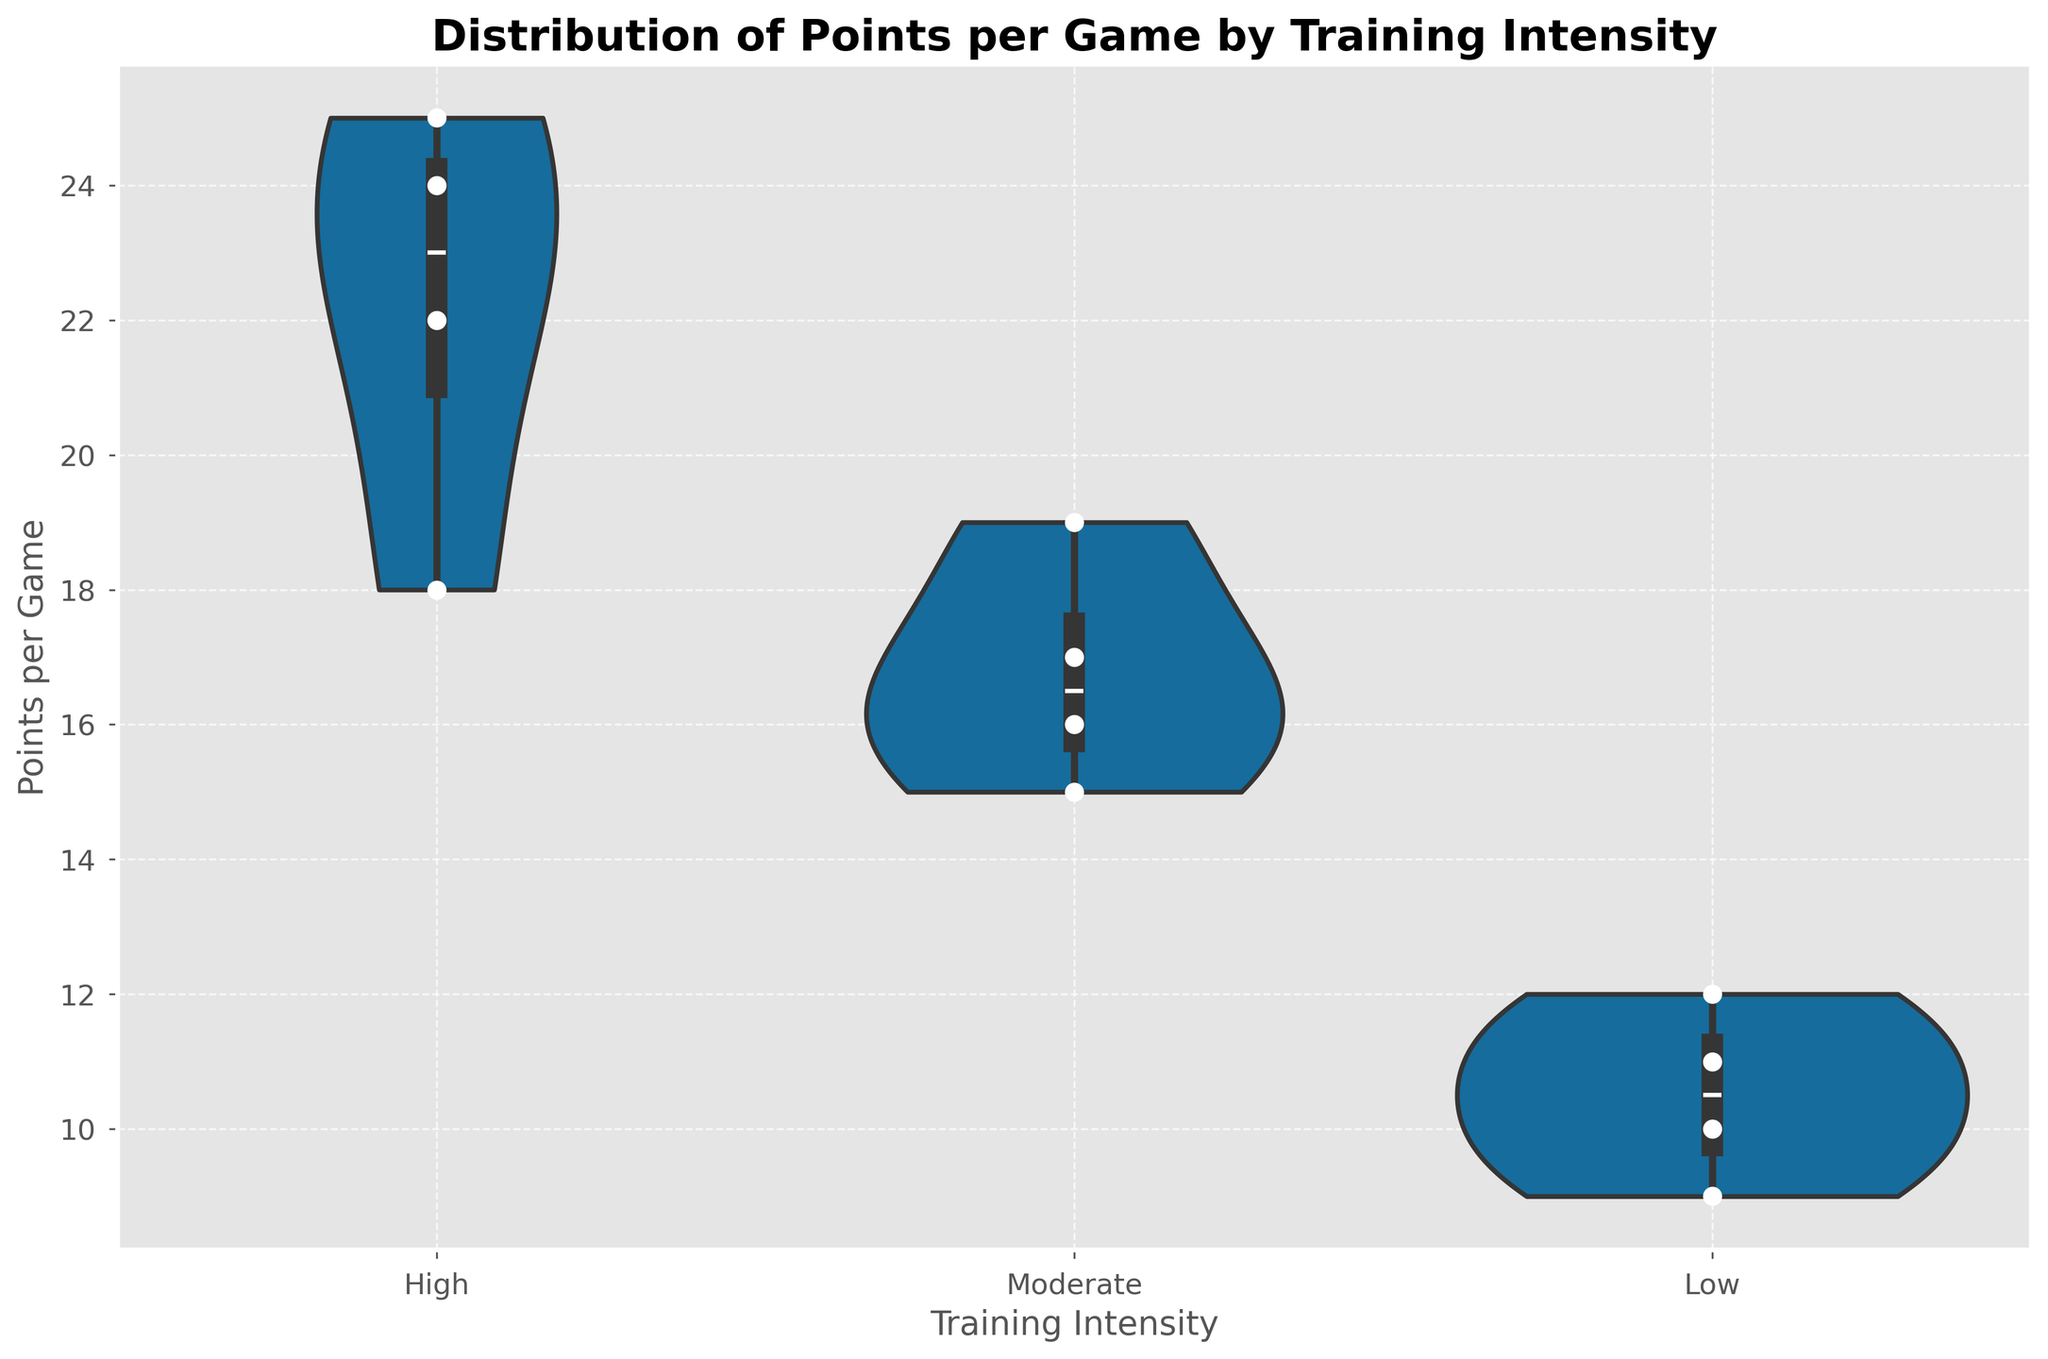What is the title of the figure? The title is shown at the top of the figure, and it provides an overview of the content of the plot.
Answer: Distribution of Points per Game by Training Intensity How many training intensity levels are represented on the x-axis? The x-axis displays the categories being compared, in this case, the different training intensity levels.
Answer: Three Which training intensity level has the highest median points per game? To determine the highest median, you observe the white dot in each violin plot, which represents the median value.
Answer: High What is the range of points per game for the 'Low' training intensity group? The range is obtained by looking at the top and bottom values of the 'Low' training intensity violin plot.
Answer: 9 to 12 Which training intensity level has the most densely packed points near the median? The density near the median is indicated by the width of the violin plot around the median (white dot).
Answer: High How many data points are represented for the 'Moderate' training intensity group? Each dot in the swarm plot represents an individual data point; count the dots for 'Moderate' training intensity.
Answer: Four Compare the spread of points per game between 'High' and 'Low' training intensities; which one is wider? The spread can be compared by the height of the violin plots.
Answer: High What is the interquartile range (IQR) for the 'High' training intensity group? The IQR is the range between the first quartile (25th percentile) and the third quartile (75th percentile) shown by the width of the darker part of the violin plot.
Answer: 18 to 25 Which training intensity group has the highest concentration of points per game at the lower end of the scale? The concentration at the lower end of the scale can be observed by the density of the violin plot towards the bottom.
Answer: Low 